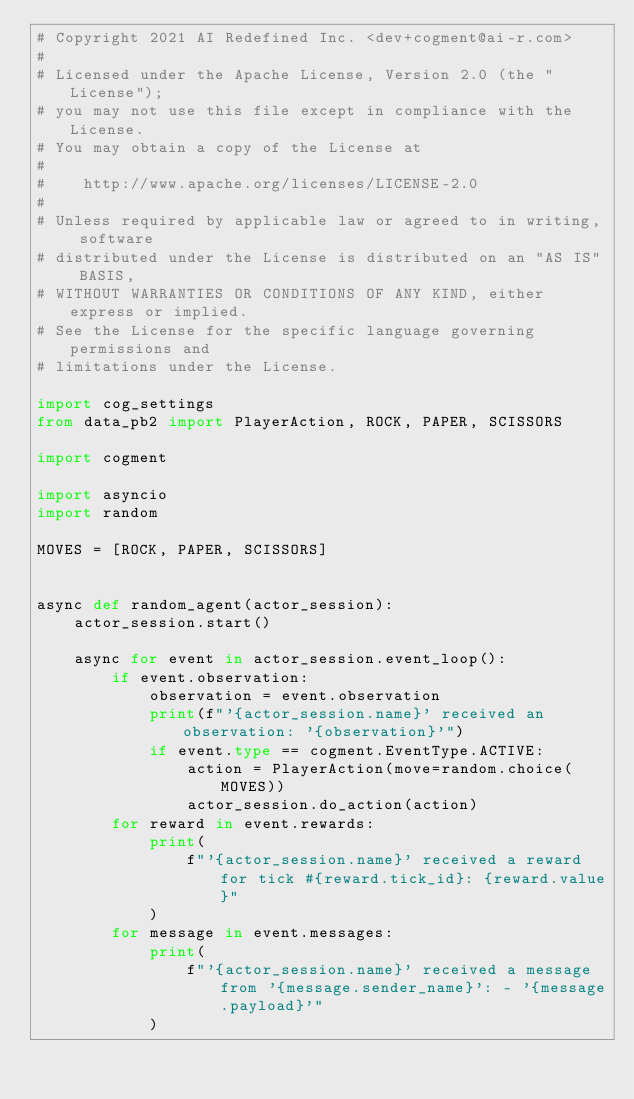<code> <loc_0><loc_0><loc_500><loc_500><_Python_># Copyright 2021 AI Redefined Inc. <dev+cogment@ai-r.com>
#
# Licensed under the Apache License, Version 2.0 (the "License");
# you may not use this file except in compliance with the License.
# You may obtain a copy of the License at
#
#    http://www.apache.org/licenses/LICENSE-2.0
#
# Unless required by applicable law or agreed to in writing, software
# distributed under the License is distributed on an "AS IS" BASIS,
# WITHOUT WARRANTIES OR CONDITIONS OF ANY KIND, either express or implied.
# See the License for the specific language governing permissions and
# limitations under the License.

import cog_settings
from data_pb2 import PlayerAction, ROCK, PAPER, SCISSORS

import cogment

import asyncio
import random

MOVES = [ROCK, PAPER, SCISSORS]


async def random_agent(actor_session):
    actor_session.start()

    async for event in actor_session.event_loop():
        if event.observation:
            observation = event.observation
            print(f"'{actor_session.name}' received an observation: '{observation}'")
            if event.type == cogment.EventType.ACTIVE:
                action = PlayerAction(move=random.choice(MOVES))
                actor_session.do_action(action)
        for reward in event.rewards:
            print(
                f"'{actor_session.name}' received a reward for tick #{reward.tick_id}: {reward.value}"
            )
        for message in event.messages:
            print(
                f"'{actor_session.name}' received a message from '{message.sender_name}': - '{message.payload}'"
            )

</code> 